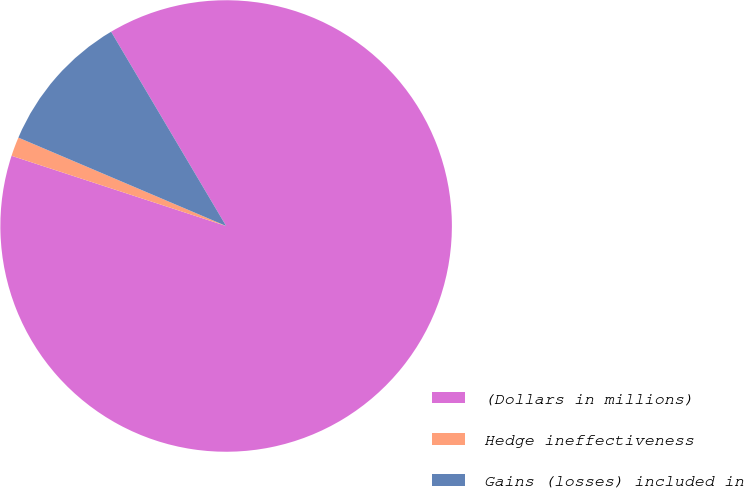Convert chart to OTSL. <chart><loc_0><loc_0><loc_500><loc_500><pie_chart><fcel>(Dollars in millions)<fcel>Hedge ineffectiveness<fcel>Gains (losses) included in<nl><fcel>88.54%<fcel>1.37%<fcel>10.09%<nl></chart> 